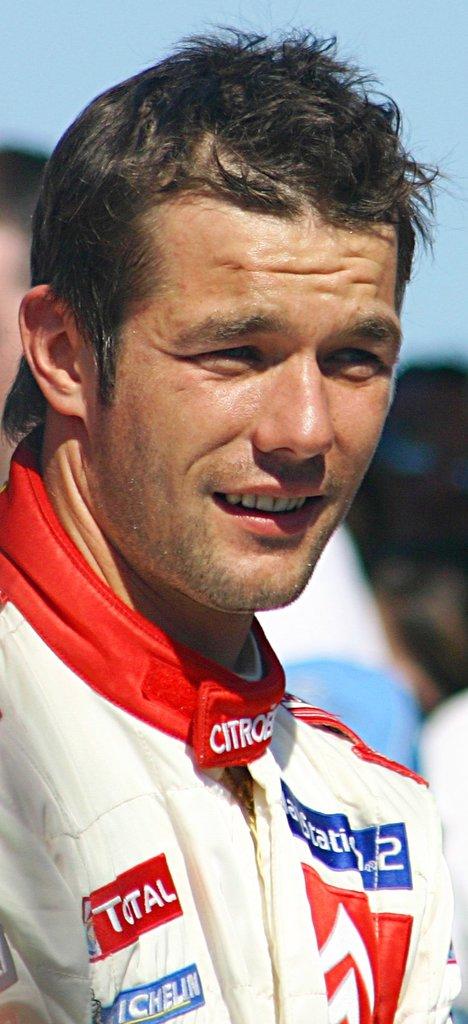What is the sponsor name on the driver's collar?
Ensure brevity in your answer.  Total. What tire brand sponsors this driver?
Offer a very short reply. Michelin. 